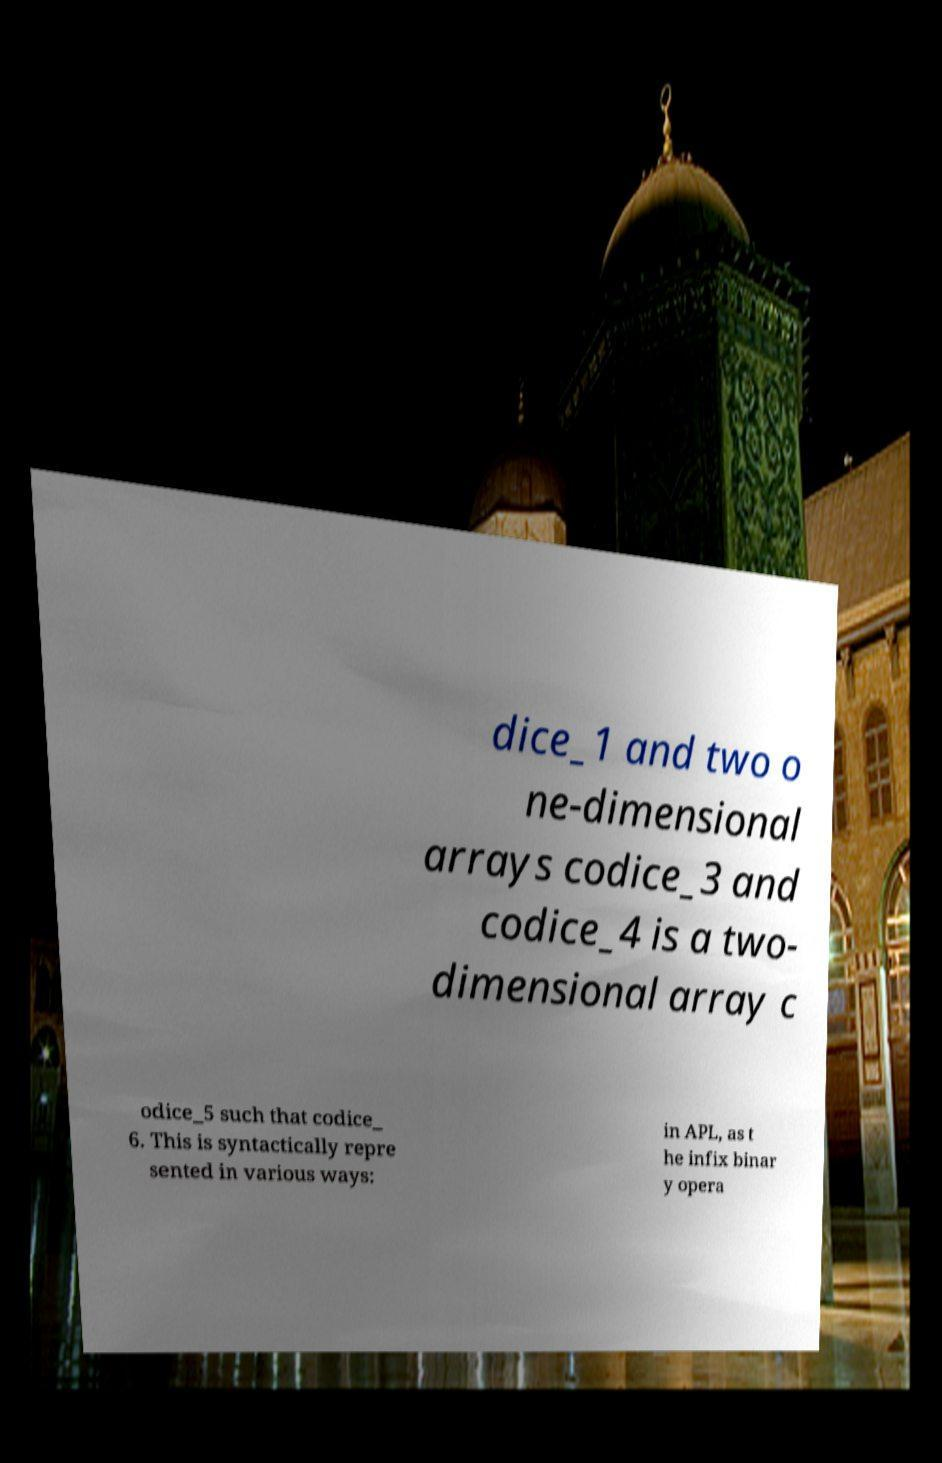There's text embedded in this image that I need extracted. Can you transcribe it verbatim? dice_1 and two o ne-dimensional arrays codice_3 and codice_4 is a two- dimensional array c odice_5 such that codice_ 6. This is syntactically repre sented in various ways: in APL, as t he infix binar y opera 